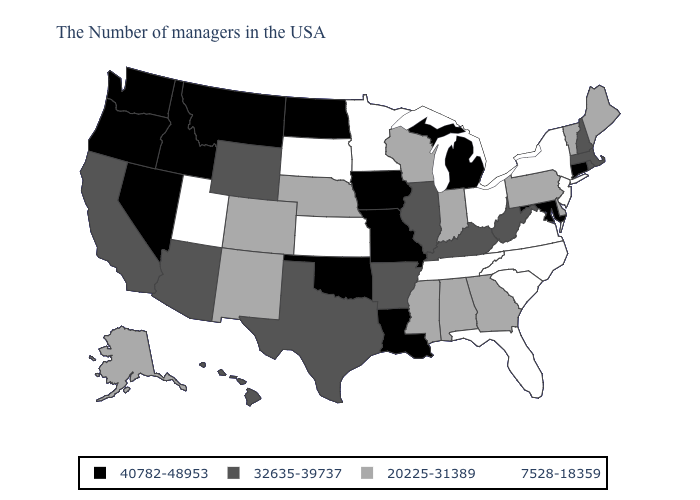What is the value of Hawaii?
Be succinct. 32635-39737. What is the highest value in the USA?
Write a very short answer. 40782-48953. What is the highest value in the USA?
Write a very short answer. 40782-48953. What is the value of Colorado?
Be succinct. 20225-31389. Which states have the highest value in the USA?
Give a very brief answer. Connecticut, Maryland, Michigan, Louisiana, Missouri, Iowa, Oklahoma, North Dakota, Montana, Idaho, Nevada, Washington, Oregon. What is the highest value in states that border Montana?
Quick response, please. 40782-48953. Does Missouri have the highest value in the USA?
Concise answer only. Yes. What is the lowest value in the USA?
Keep it brief. 7528-18359. Name the states that have a value in the range 40782-48953?
Be succinct. Connecticut, Maryland, Michigan, Louisiana, Missouri, Iowa, Oklahoma, North Dakota, Montana, Idaho, Nevada, Washington, Oregon. Name the states that have a value in the range 20225-31389?
Write a very short answer. Maine, Vermont, Delaware, Pennsylvania, Georgia, Indiana, Alabama, Wisconsin, Mississippi, Nebraska, Colorado, New Mexico, Alaska. Among the states that border Rhode Island , does Connecticut have the highest value?
Quick response, please. Yes. Does South Carolina have a lower value than Oregon?
Keep it brief. Yes. Among the states that border Delaware , which have the lowest value?
Quick response, please. New Jersey. What is the value of Connecticut?
Quick response, please. 40782-48953. Does Alaska have a lower value than Ohio?
Answer briefly. No. 